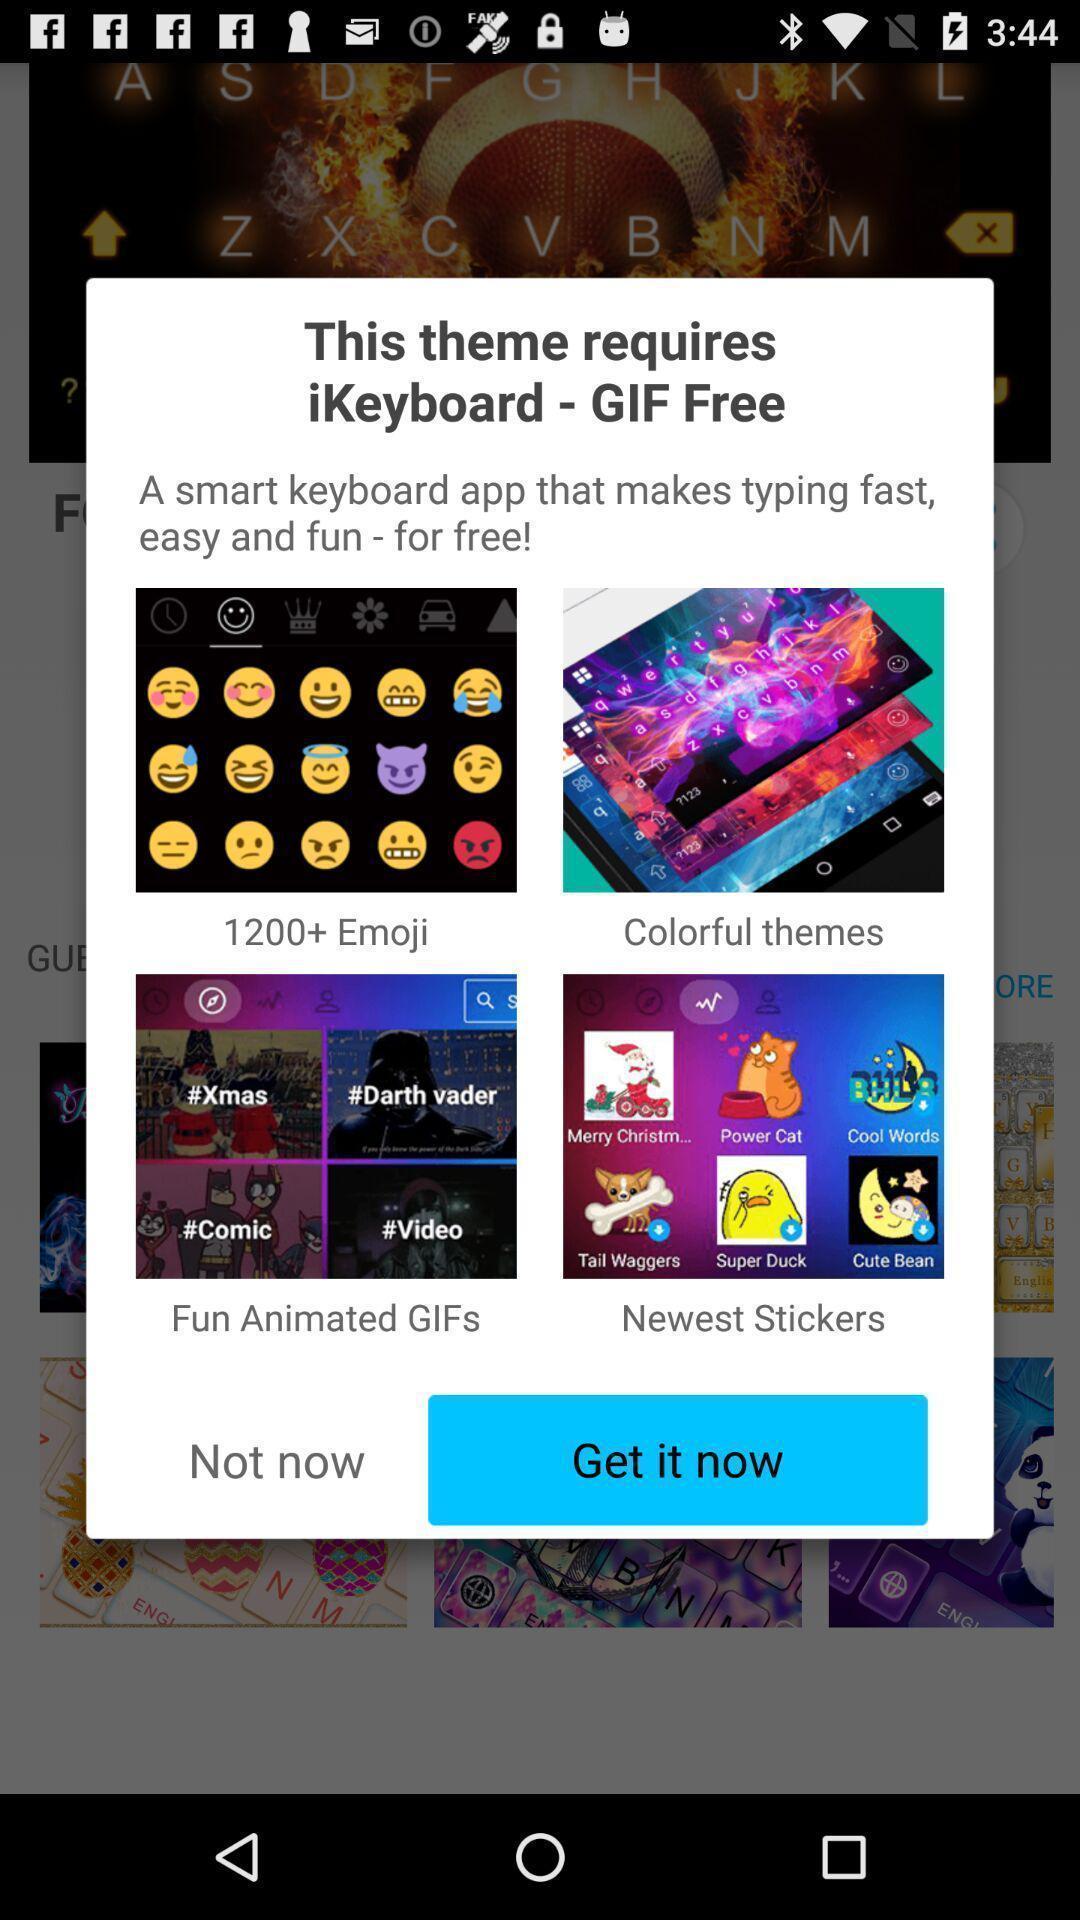What can you discern from this picture? Pop-up displaying menu of emojis. 